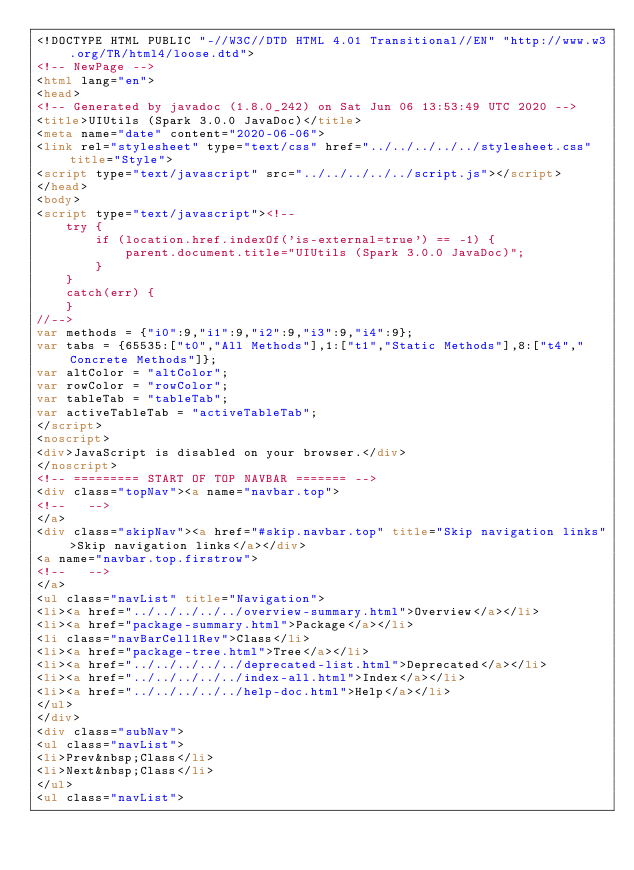<code> <loc_0><loc_0><loc_500><loc_500><_HTML_><!DOCTYPE HTML PUBLIC "-//W3C//DTD HTML 4.01 Transitional//EN" "http://www.w3.org/TR/html4/loose.dtd">
<!-- NewPage -->
<html lang="en">
<head>
<!-- Generated by javadoc (1.8.0_242) on Sat Jun 06 13:53:49 UTC 2020 -->
<title>UIUtils (Spark 3.0.0 JavaDoc)</title>
<meta name="date" content="2020-06-06">
<link rel="stylesheet" type="text/css" href="../../../../../stylesheet.css" title="Style">
<script type="text/javascript" src="../../../../../script.js"></script>
</head>
<body>
<script type="text/javascript"><!--
    try {
        if (location.href.indexOf('is-external=true') == -1) {
            parent.document.title="UIUtils (Spark 3.0.0 JavaDoc)";
        }
    }
    catch(err) {
    }
//-->
var methods = {"i0":9,"i1":9,"i2":9,"i3":9,"i4":9};
var tabs = {65535:["t0","All Methods"],1:["t1","Static Methods"],8:["t4","Concrete Methods"]};
var altColor = "altColor";
var rowColor = "rowColor";
var tableTab = "tableTab";
var activeTableTab = "activeTableTab";
</script>
<noscript>
<div>JavaScript is disabled on your browser.</div>
</noscript>
<!-- ========= START OF TOP NAVBAR ======= -->
<div class="topNav"><a name="navbar.top">
<!--   -->
</a>
<div class="skipNav"><a href="#skip.navbar.top" title="Skip navigation links">Skip navigation links</a></div>
<a name="navbar.top.firstrow">
<!--   -->
</a>
<ul class="navList" title="Navigation">
<li><a href="../../../../../overview-summary.html">Overview</a></li>
<li><a href="package-summary.html">Package</a></li>
<li class="navBarCell1Rev">Class</li>
<li><a href="package-tree.html">Tree</a></li>
<li><a href="../../../../../deprecated-list.html">Deprecated</a></li>
<li><a href="../../../../../index-all.html">Index</a></li>
<li><a href="../../../../../help-doc.html">Help</a></li>
</ul>
</div>
<div class="subNav">
<ul class="navList">
<li>Prev&nbsp;Class</li>
<li>Next&nbsp;Class</li>
</ul>
<ul class="navList"></code> 